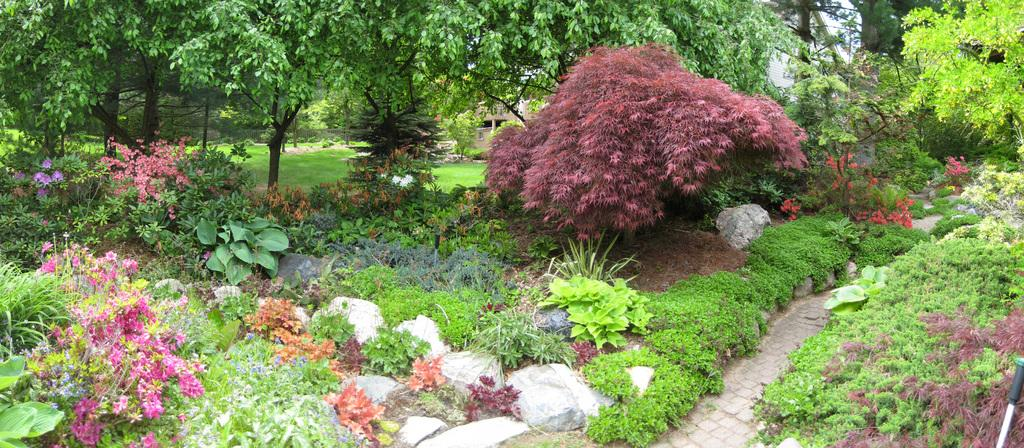What types of vegetation can be seen in the image? There are many plants and trees in the image. Can you describe the background of the image? There is a building visible in the background of the image. How many shoes can be seen hanging from the trees in the image? There are no shoes hanging from the trees in the image; it features plants, trees, and a building in the background. 